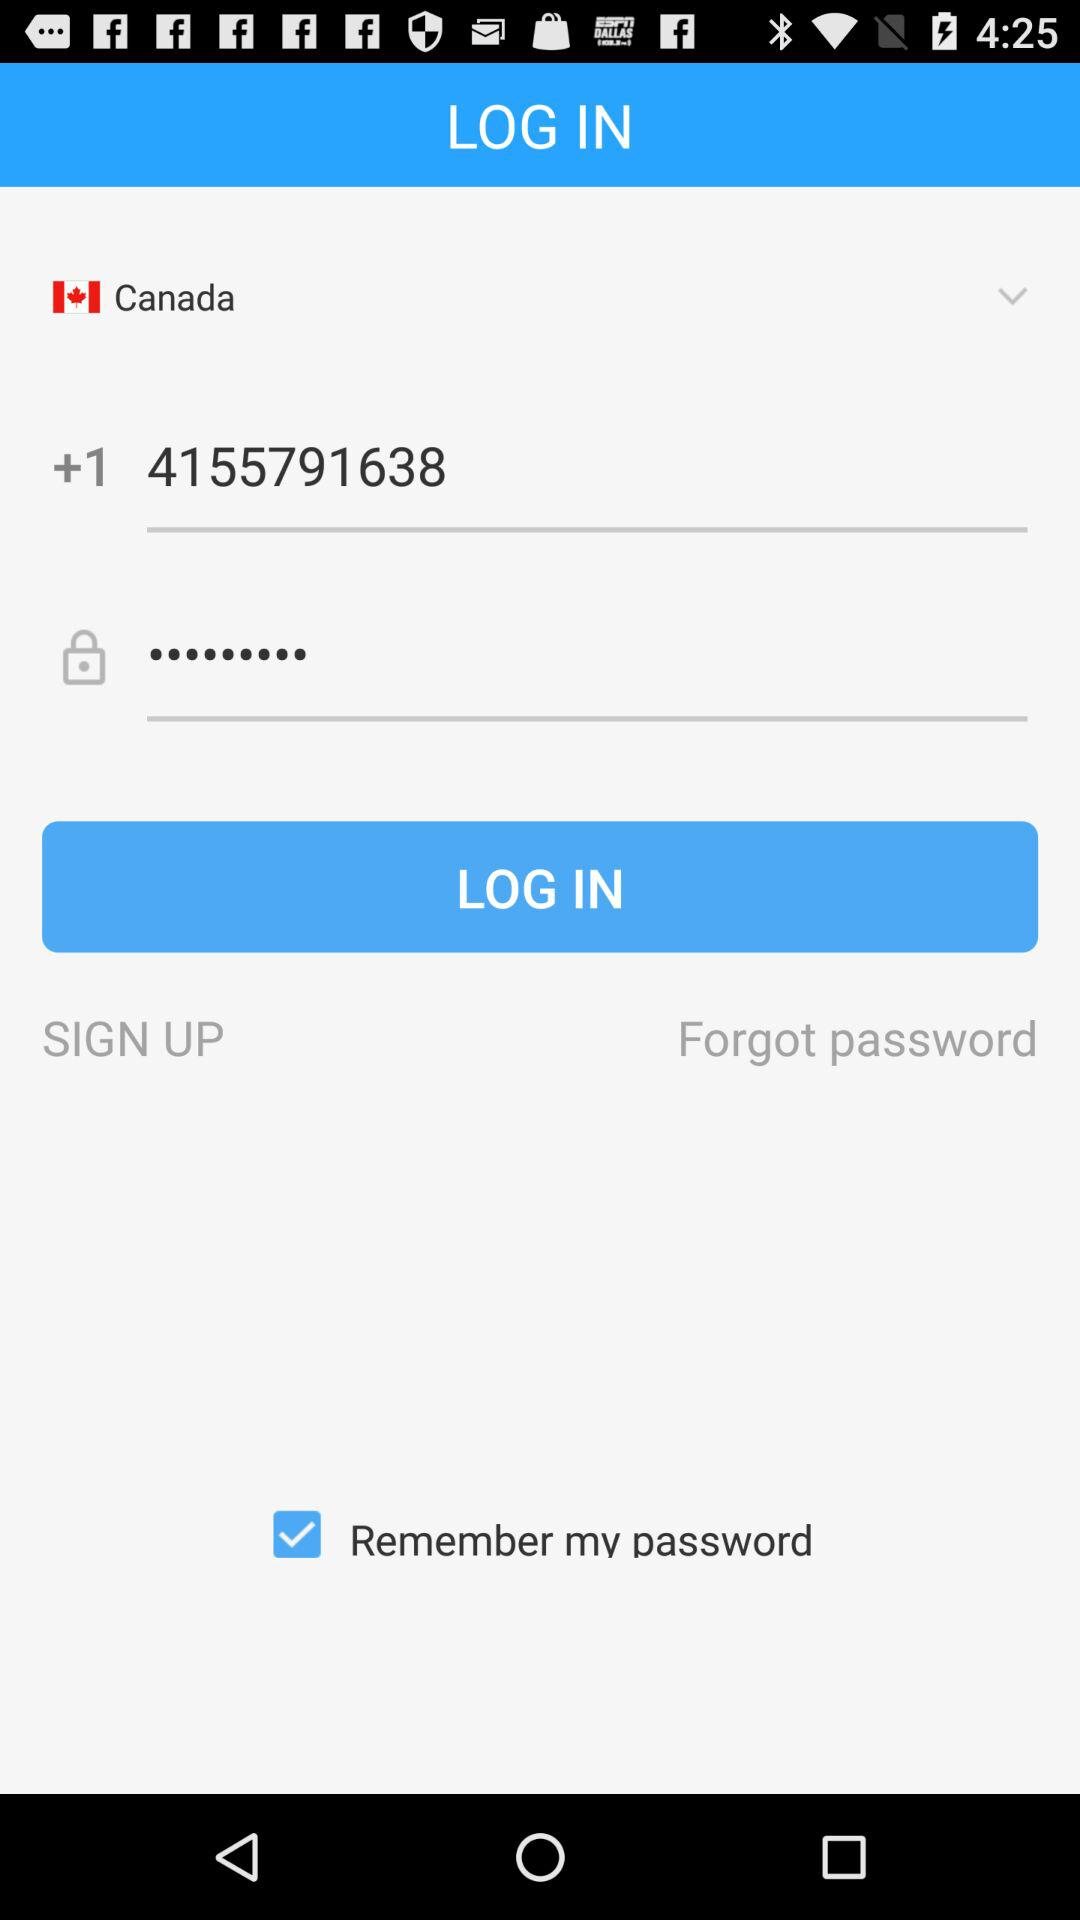What is the status of "Remember my password"? The status of "Remember my password" is "on". 